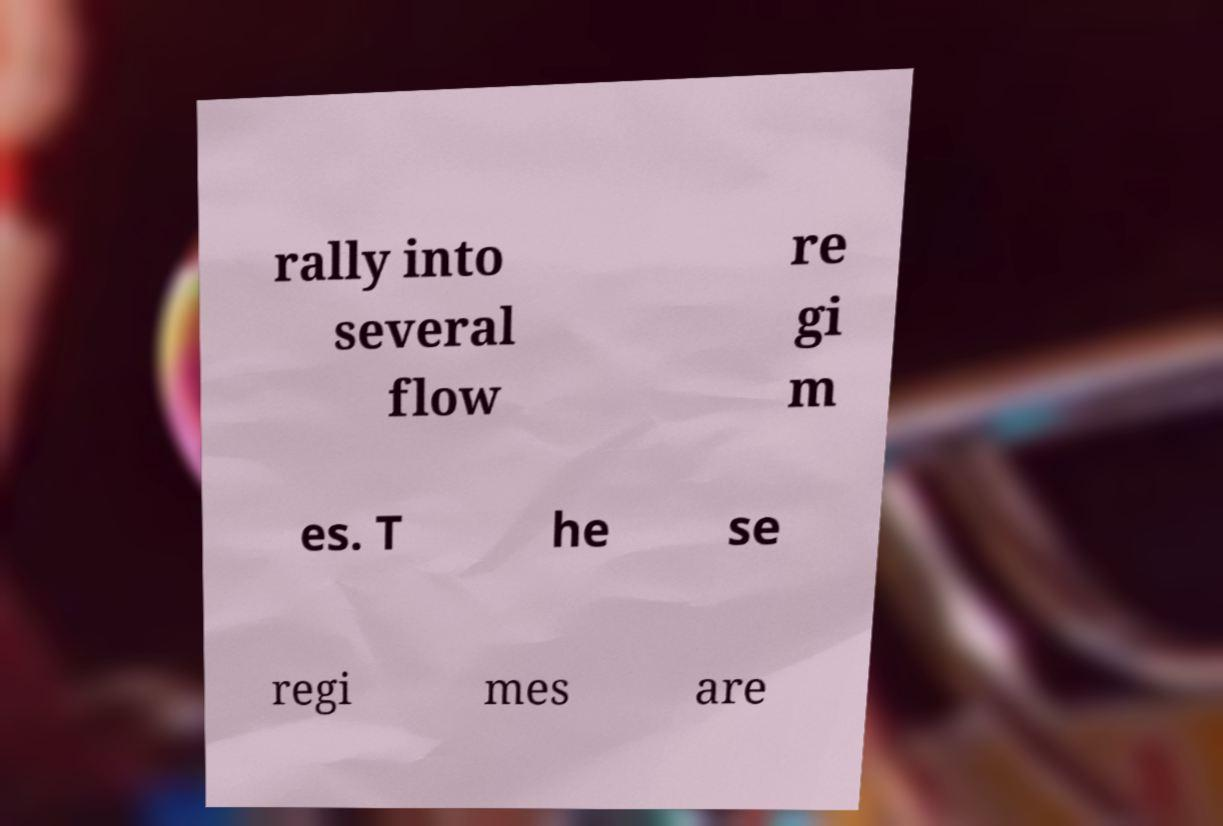Can you read and provide the text displayed in the image?This photo seems to have some interesting text. Can you extract and type it out for me? rally into several flow re gi m es. T he se regi mes are 